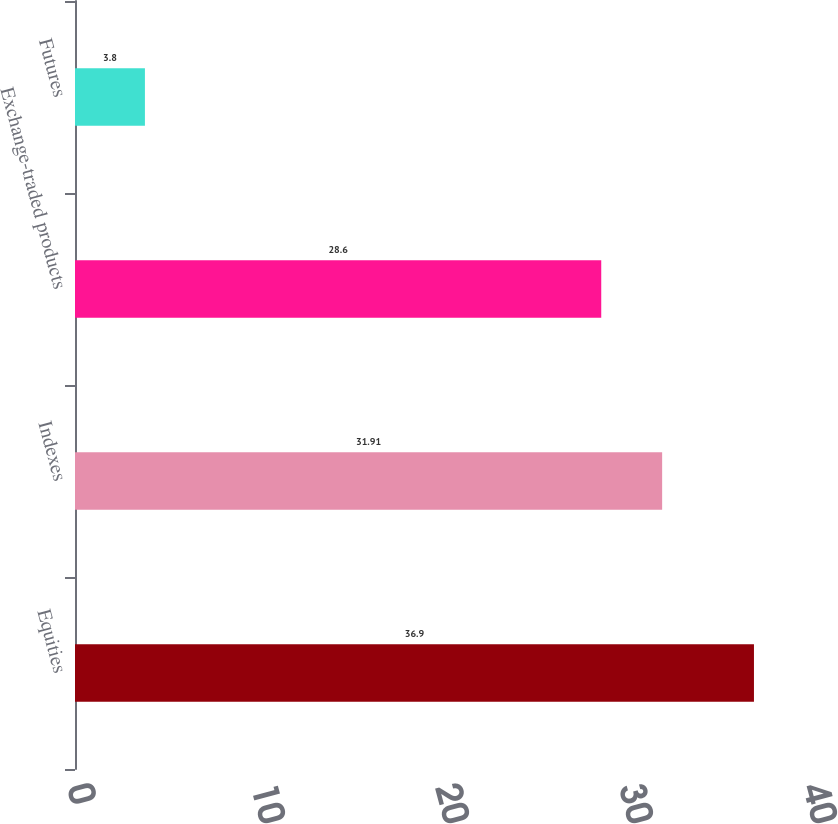<chart> <loc_0><loc_0><loc_500><loc_500><bar_chart><fcel>Equities<fcel>Indexes<fcel>Exchange-traded products<fcel>Futures<nl><fcel>36.9<fcel>31.91<fcel>28.6<fcel>3.8<nl></chart> 